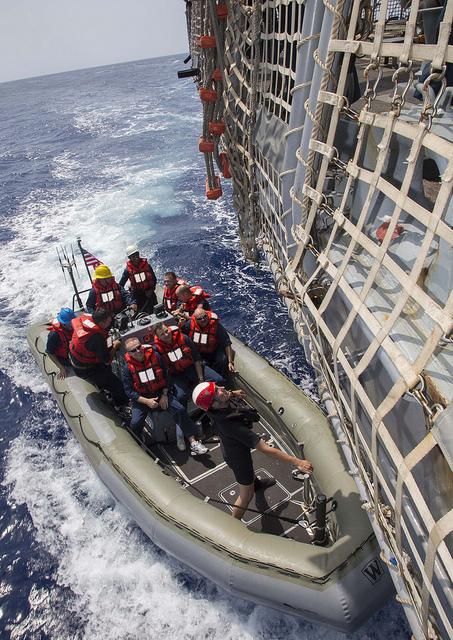Is the man in front looking up?
Give a very brief answer. Yes. What flag is on the small boat?
Be succinct. American. Is this happening in a water body?
Be succinct. Yes. 